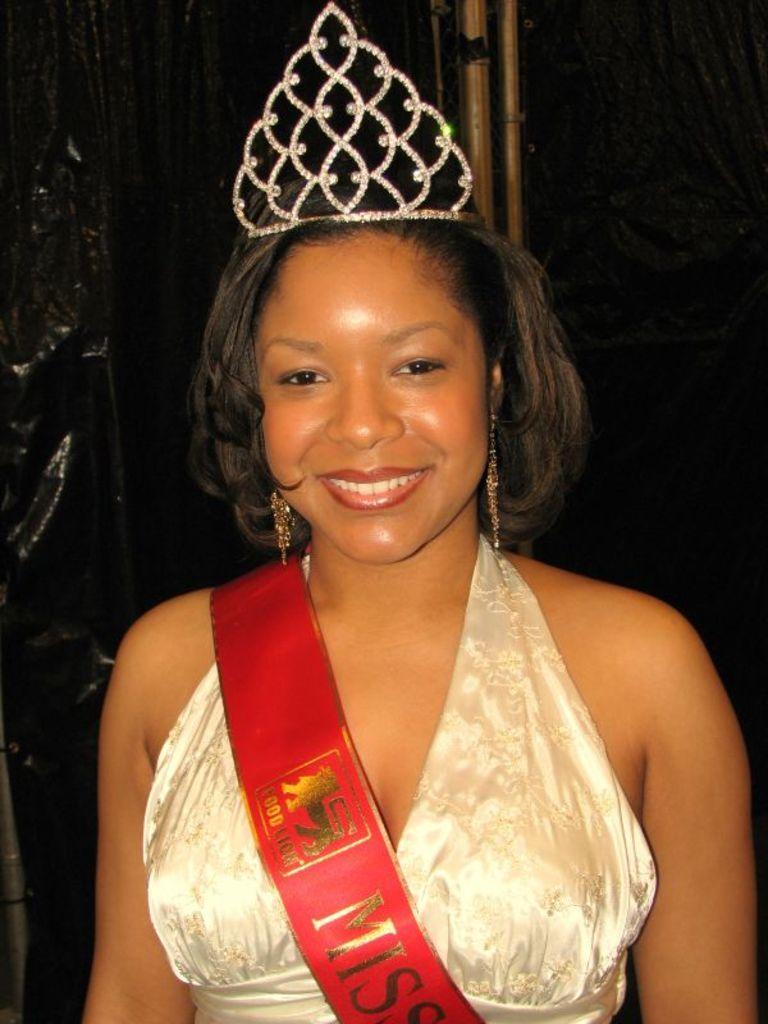Describe this image in one or two sentences. Here in this picture we can see a woman present and we can see she is smiling and wearing a crown and ear rings on her over there. 